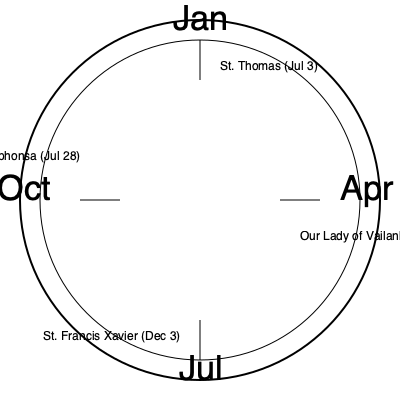Based on the circular calendar diagram, which feast day specific to Indian Catholic traditions falls closest to the beginning of the liturgical year (Advent)? To answer this question, we need to follow these steps:

1. Understand the liturgical calendar:
   - The liturgical year begins with Advent, which typically starts in late November or early December.

2. Identify the feast days shown in the diagram:
   - St. Thomas (July 3)
   - Our Lady of Vailankanni (September 8)
   - St. Francis Xavier (December 3)
   - St. Alphonsa (July 28)

3. Consider the proximity of each feast to the beginning of Advent:
   - St. Thomas and St. Alphonsa fall in July, which is far from Advent.
   - Our Lady of Vailankanni is in September, which is closer but still a few months away.
   - St. Francis Xavier is on December 3, which is typically very close to or sometimes even within the Advent season.

4. Conclude that St. Francis Xavier's feast day (December 3) is the closest to the beginning of the liturgical year among the given options.
Answer: St. Francis Xavier (December 3) 